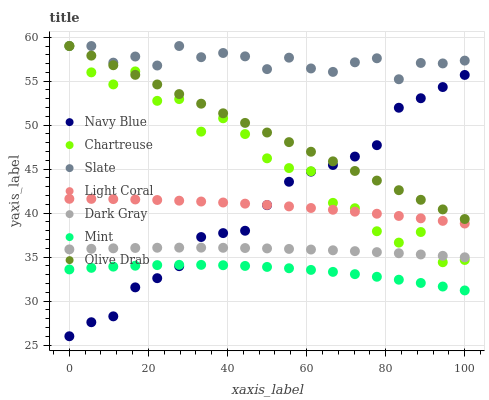Does Mint have the minimum area under the curve?
Answer yes or no. Yes. Does Slate have the maximum area under the curve?
Answer yes or no. Yes. Does Navy Blue have the minimum area under the curve?
Answer yes or no. No. Does Navy Blue have the maximum area under the curve?
Answer yes or no. No. Is Olive Drab the smoothest?
Answer yes or no. Yes. Is Chartreuse the roughest?
Answer yes or no. Yes. Is Navy Blue the smoothest?
Answer yes or no. No. Is Navy Blue the roughest?
Answer yes or no. No. Does Navy Blue have the lowest value?
Answer yes or no. Yes. Does Slate have the lowest value?
Answer yes or no. No. Does Olive Drab have the highest value?
Answer yes or no. Yes. Does Navy Blue have the highest value?
Answer yes or no. No. Is Light Coral less than Olive Drab?
Answer yes or no. Yes. Is Light Coral greater than Mint?
Answer yes or no. Yes. Does Navy Blue intersect Light Coral?
Answer yes or no. Yes. Is Navy Blue less than Light Coral?
Answer yes or no. No. Is Navy Blue greater than Light Coral?
Answer yes or no. No. Does Light Coral intersect Olive Drab?
Answer yes or no. No. 